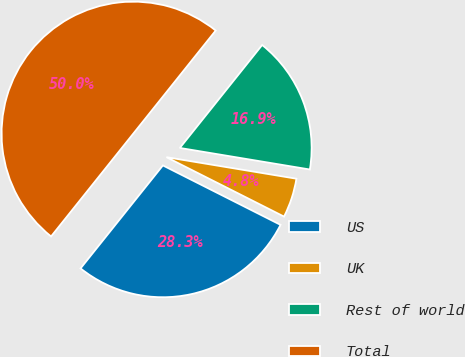<chart> <loc_0><loc_0><loc_500><loc_500><pie_chart><fcel>US<fcel>UK<fcel>Rest of world<fcel>Total<nl><fcel>28.29%<fcel>4.83%<fcel>16.88%<fcel>50.0%<nl></chart> 